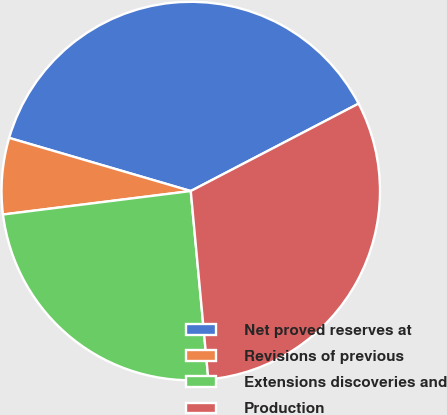Convert chart to OTSL. <chart><loc_0><loc_0><loc_500><loc_500><pie_chart><fcel>Net proved reserves at<fcel>Revisions of previous<fcel>Extensions discoveries and<fcel>Production<nl><fcel>37.82%<fcel>6.51%<fcel>24.5%<fcel>31.16%<nl></chart> 